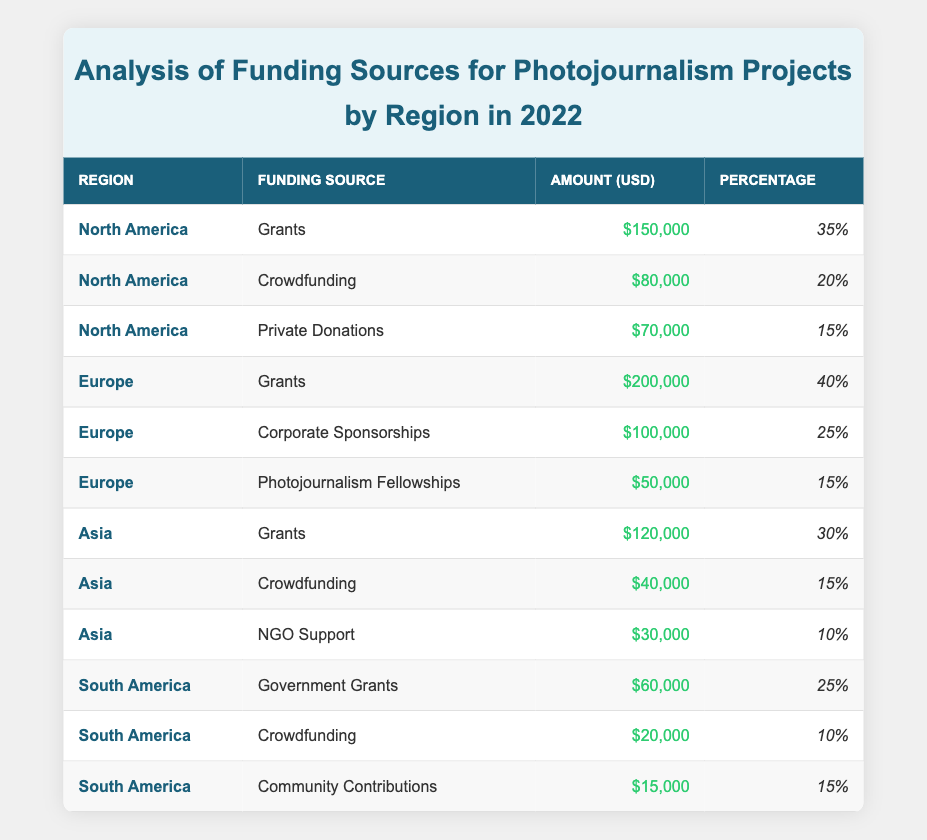What is the total funding amount for photojournalism projects in North America? Adding the amounts for North America: Grants ($150,000) + Crowdfunding ($80,000) + Private Donations ($70,000) = $300,000
Answer: 300,000 Which funding source had the highest percentage in Europe? The funding source with the highest percentage in Europe is Grants, with a percentage of 40%.
Answer: Grants What percentage of photojournalism projects in Asia is supported by NGO Support? NGO Support in Asia is 10% of the total funding sources in that region.
Answer: 10% Is the total funding for photojournalism projects in South America greater than that in Asia? Total funding for South America is $95,000 (Government Grants $60,000 + Crowdfunding $20,000 + Community Contributions $15,000) and for Asia is $190,000 (Grants $120,000 + Crowdfunding $40,000 + NGO Support $30,000). Since $95,000 is less than $190,000, the statement is false.
Answer: No What is the average funding amount for photojournalism projects across all regions? The total amounts across all regions are: North America $300,000 + Europe $350,000 + Asia $190,000 + South America $95,000 = $935,000. There are 12 funding sources, thus the average is $935,000 / 12 = $77,916.67.
Answer: 77,916.67 Which region had the least amount of funding, and what was the source? South America had the least amount of individual funding sources, with Community Contributions being 15,000, which is the lowest individual funding amount across all regions.
Answer: South America, Community Contributions How much funding did Crowdfunding generate in Europe compared to North America? In Europe, Crowdfunding is not listed, meaning it generated $0, while in North America, Crowdfunding generated $80,000. Therefore, Crowdfunding generated $80,000 more in North America.
Answer: 80,000 more What proportion of funding in Europe is accounted for by Grants? The total funding in Europe is $350,000, with Grants contributing $200,000. The proportion is calculated as $200,000 / $350,000 = 0.5714, or 57.14%.
Answer: 57.14% 